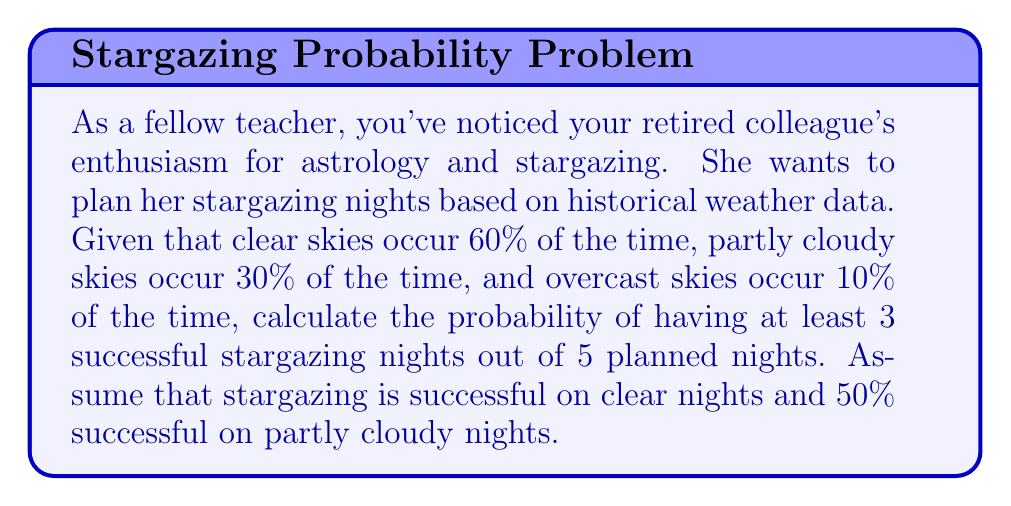Could you help me with this problem? Let's approach this step-by-step:

1) First, we need to calculate the probability of a successful stargazing night:
   
   $P(\text{success}) = P(\text{clear}) + P(\text{partly cloudy}) \cdot P(\text{success | partly cloudy})$
   $= 0.60 + 0.30 \cdot 0.50 = 0.60 + 0.15 = 0.75$

2) Now, we can treat this as a binomial probability problem. We want the probability of at least 3 successes out of 5 trials, where each trial has a 0.75 probability of success.

3) The probability of exactly $k$ successes in $n$ trials is given by the binomial probability formula:

   $P(X = k) = \binom{n}{k} p^k (1-p)^{n-k}$

   Where $n$ is the number of trials, $k$ is the number of successes, $p$ is the probability of success on each trial.

4) We need to calculate this for $k = 3$, $k = 4$, and $k = 5$, and sum these probabilities:

   $P(X \geq 3) = P(X = 3) + P(X = 4) + P(X = 5)$

5) Let's calculate each term:

   $P(X = 3) = \binom{5}{3} 0.75^3 (1-0.75)^{5-3} = 10 \cdot 0.75^3 \cdot 0.25^2 = 0.2637$

   $P(X = 4) = \binom{5}{4} 0.75^4 (1-0.75)^{5-4} = 5 \cdot 0.75^4 \cdot 0.25^1 = 0.3955$

   $P(X = 5) = \binom{5}{5} 0.75^5 (1-0.75)^{5-5} = 1 \cdot 0.75^5 \cdot 0.25^0 = 0.2373$

6) Now, we sum these probabilities:

   $P(X \geq 3) = 0.2637 + 0.3955 + 0.2373 = 0.8965$

Therefore, the probability of having at least 3 successful stargazing nights out of 5 planned nights is approximately 0.8965 or 89.65%.
Answer: $0.8965$ or $89.65\%$ 